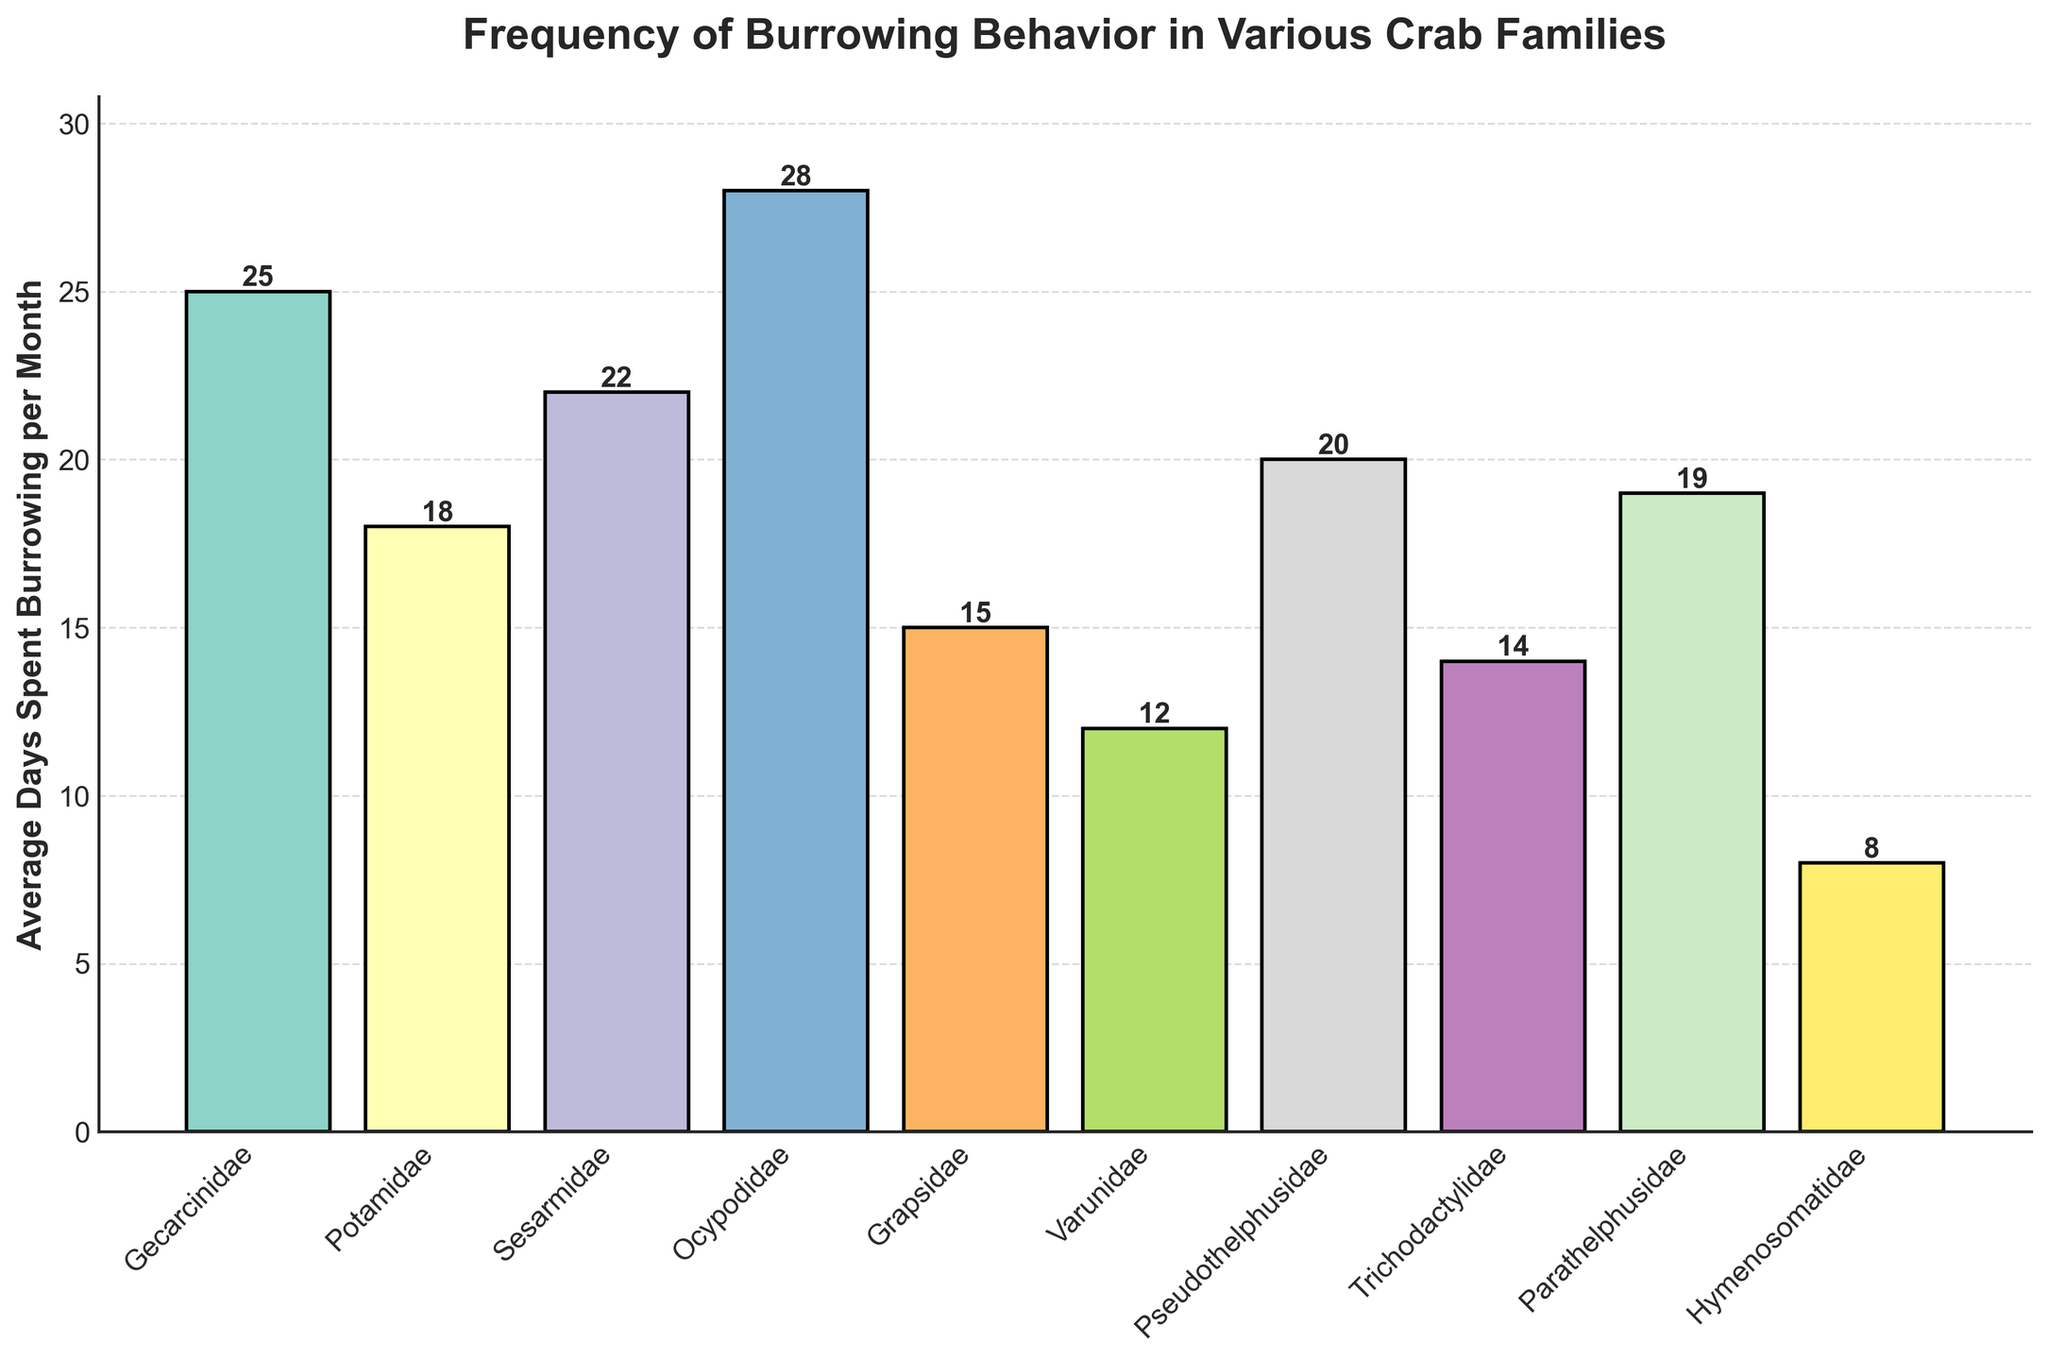Which crab family spends the most days burrowing per month? The bar chart displays the average days spent burrowing for each crab family. The bar corresponding to the Ocypodidae family reaches the highest value.
Answer: Ocypodidae Which crab family spends the least days burrowing per month? The bar chart shows different crab families and their burrowing days. The bar corresponding to the Hymenosomatidae family has the shortest height.
Answer: Hymenosomatidae What is the difference between the average days spent burrowing per month of the Ocypodidae and Varunidae families? The chart indicates the Ocypodidae family averages 28 days, and the Varunidae family averages 12 days of burrowing per month. The difference is calculated as 28 - 12.
Answer: 16 How many more days on average does Sesarmidae spend burrowing compared to Grapsidae? Sesarmidae averages 22 days, while Grapsidae averages 15 days. The difference is 22 - 15.
Answer: 7 Which three crab families spend an average of 20 or more days per month burrowing? Observing the chart, the bars for Gecarcinidae (25 days), Sesarmidae (22 days), Ocypodidae (28 days), and Pseudothelphusidae (20 days) reach or exceed the 20-day mark.
Answer: Gecarcinidae, Sesarmidae, Ocypodidae, Pseudothelphusidae Are there more crab families that spend over 20 days burrowing or under 20 days burrowing per month? The chart shows four families (Gecarcinidae, Sesarmidae, Ocypodidae, Pseudothelphusidae) spending over 20 days and six families spending under 20 days per month burrowing.
Answer: Under 20 days What is the average (mean) number of days spent burrowing per month for all the crab families displayed? Adding up the days spent burrowing per month: 25 (Gecarcinidae) + 18 (Potamidae) + 22 (Sesarmidae) + 28 (Ocypodidae) + 15 (Grapsidae) + 12 (Varunidae) + 20 (Pseudothelphusidae) + 14 (Trichodactylidae) + 19 (Parathelphusidae) + 8 (Hymenosomatidae) = 181. Dividing by the number of families (10) gives the average 181 / 10.
Answer: 18.1 Which crab families have similar burrowing behaviors, indicated by almost equal average days spent burrowing per month? The chart shows Potamidae (18 days), Pseudothelphusidae (20 days), and Parathelphusidae (19 days) with nearly equal average burrowing days.
Answer: Potamidae, Pseudothelphusidae, Parathelphusidae What is the range of average days spent burrowing per month among the crab families? The range is found by subtracting the minimum value (Hymenosomatidae, 8 days) from the maximum value (Ocypodidae, 28 days).
Answer: 20 What is the median value of average days spent burrowing per month for the crab families? Ordering the values: 8, 12, 14, 15, 18, 19, 20, 22, 25, 28. The median is the average of the 5th and 6th values: (18 + 19) / 2.
Answer: 18.5 